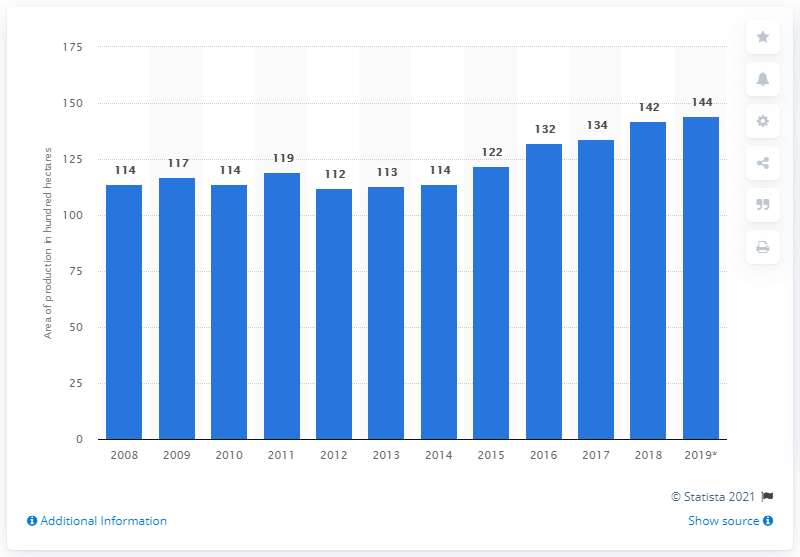Give some essential details in this illustration. In 2008, the total area used for tulip bulbs in the Netherlands increased. 